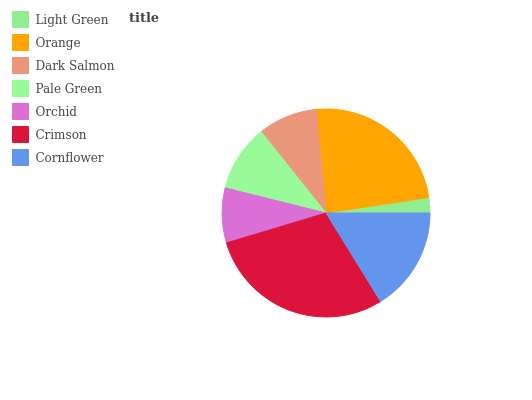Is Light Green the minimum?
Answer yes or no. Yes. Is Crimson the maximum?
Answer yes or no. Yes. Is Orange the minimum?
Answer yes or no. No. Is Orange the maximum?
Answer yes or no. No. Is Orange greater than Light Green?
Answer yes or no. Yes. Is Light Green less than Orange?
Answer yes or no. Yes. Is Light Green greater than Orange?
Answer yes or no. No. Is Orange less than Light Green?
Answer yes or no. No. Is Pale Green the high median?
Answer yes or no. Yes. Is Pale Green the low median?
Answer yes or no. Yes. Is Orange the high median?
Answer yes or no. No. Is Orchid the low median?
Answer yes or no. No. 